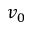Convert formula to latex. <formula><loc_0><loc_0><loc_500><loc_500>v _ { 0 }</formula> 